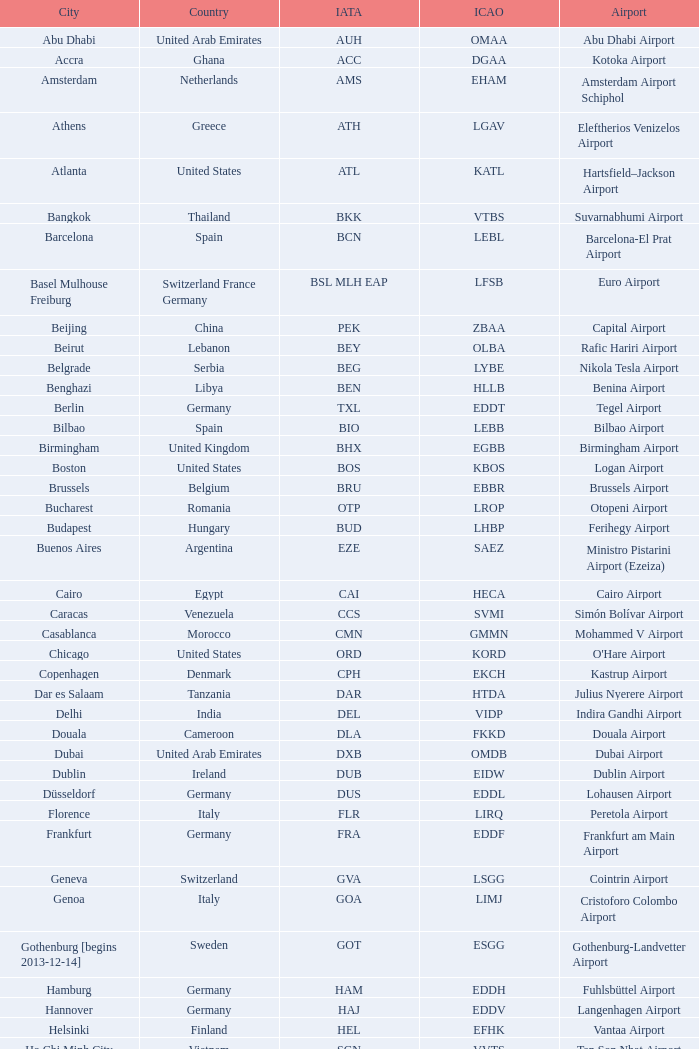Which city houses fuhlsbüttel airport? Hamburg. 